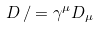<formula> <loc_0><loc_0><loc_500><loc_500>D \, / = \gamma ^ { \mu } D _ { \mu }</formula> 